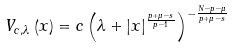<formula> <loc_0><loc_0><loc_500><loc_500>V _ { c , \lambda } \left ( x \right ) = c \left ( \lambda + \left | x \right | ^ { \frac { p + \mu - s } { p - 1 } } \right ) ^ { - \frac { N - p - \mu } { p + \mu - s } }</formula> 